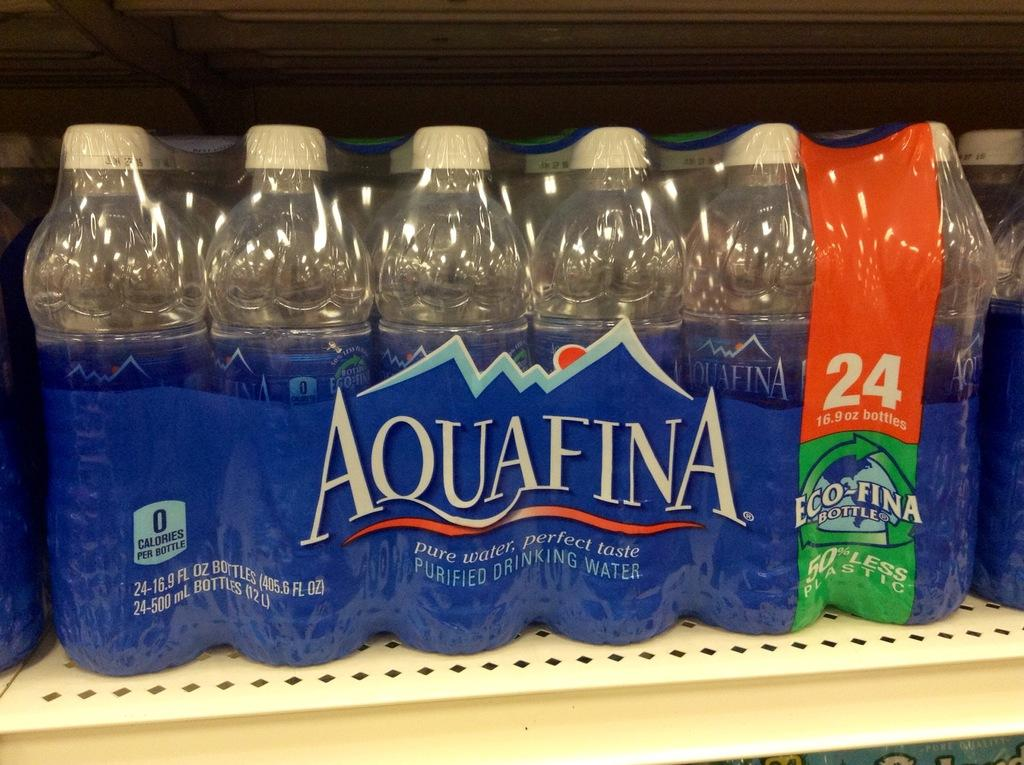<image>
Provide a brief description of the given image. A pack of 24 bottles of Aquafina water sitting on a store shelf. 